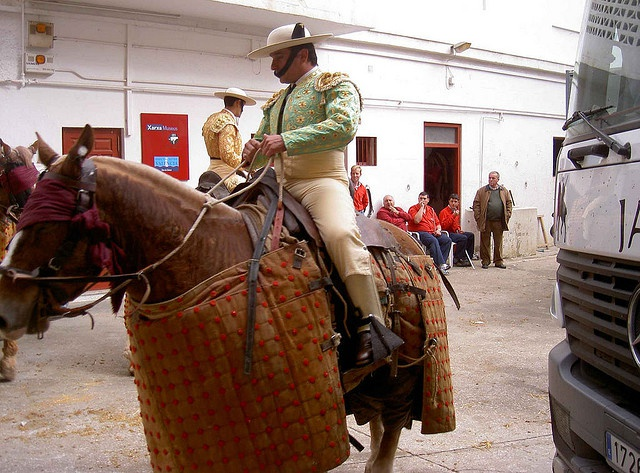Describe the objects in this image and their specific colors. I can see horse in gray, maroon, and black tones, bus in gray, black, and darkgray tones, people in gray, olive, ivory, and black tones, people in gray, ivory, tan, and brown tones, and people in gray, black, and maroon tones in this image. 